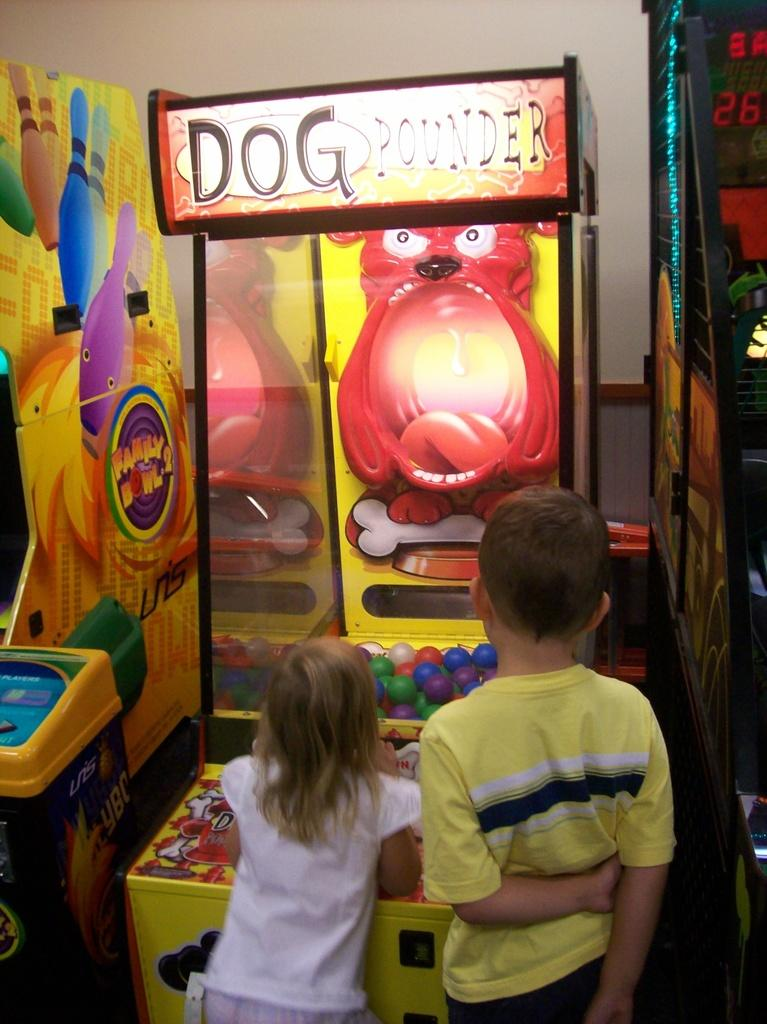Who is present in the image? There is a boy and a girl in the image. What are the boy and girl doing? The boy and girl are standing. What can be seen in front of the boy and girl? There are slot machines in front of the boy and girl. What is visible in the background of the image? There is a wall in the background of the image. Can you tell me how many strangers are standing near the dock in the image? There are no strangers or docks present in the image. What type of soda is the boy holding in the image? There is no soda visible in the image; the boy and girl are standing near slot machines. 